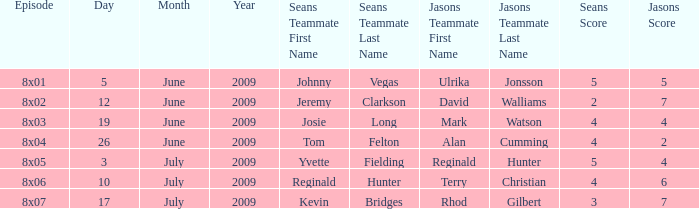What is the broadcast date where Jason's team is Rhod Gilbert and Shappi Khorsandi? 17 July 2009. 